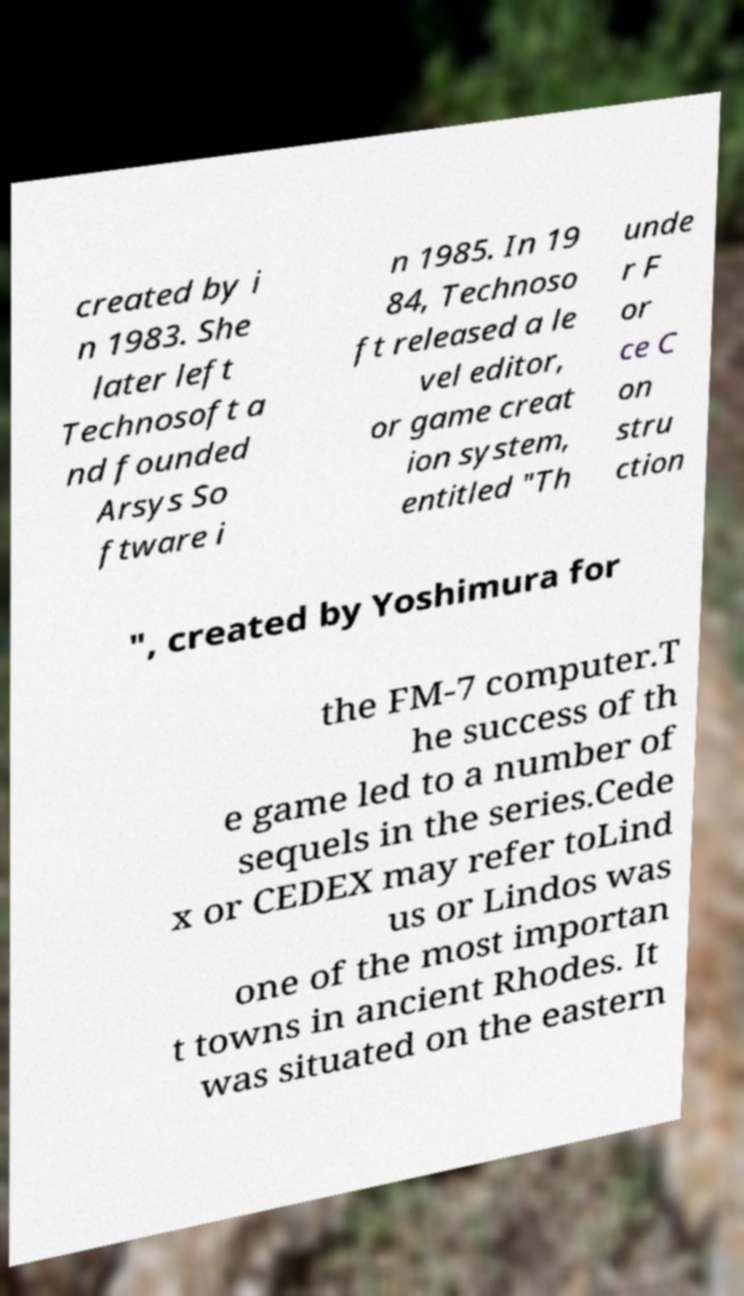Can you read and provide the text displayed in the image?This photo seems to have some interesting text. Can you extract and type it out for me? created by i n 1983. She later left Technosoft a nd founded Arsys So ftware i n 1985. In 19 84, Technoso ft released a le vel editor, or game creat ion system, entitled "Th unde r F or ce C on stru ction ", created by Yoshimura for the FM-7 computer.T he success of th e game led to a number of sequels in the series.Cede x or CEDEX may refer toLind us or Lindos was one of the most importan t towns in ancient Rhodes. It was situated on the eastern 